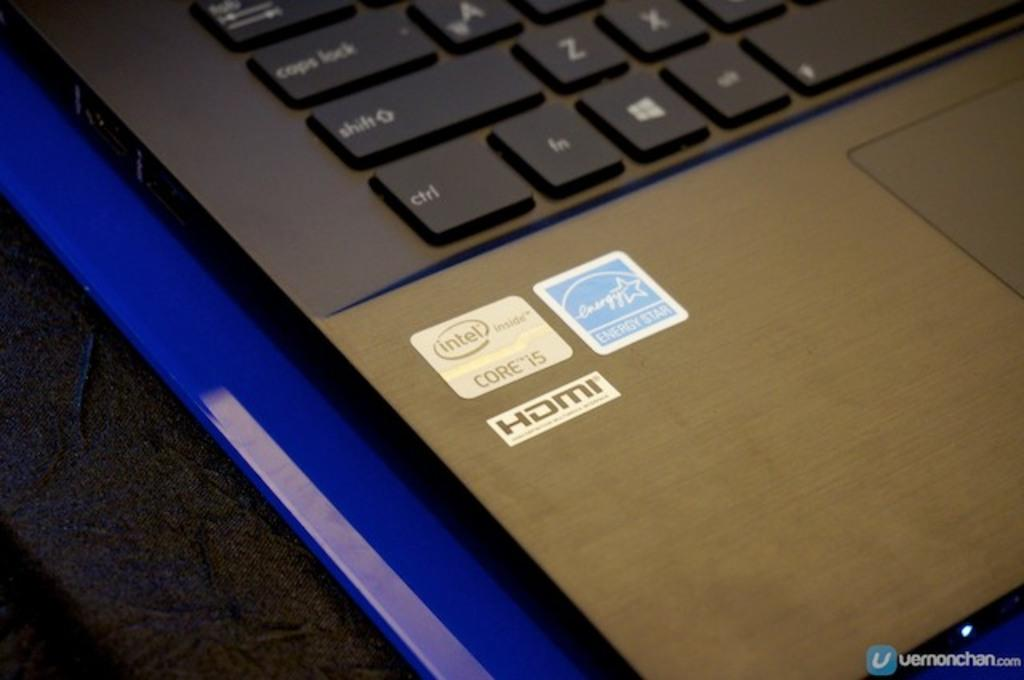Provide a one-sentence caption for the provided image. A close up of a laptop with a sticker that says intel and HDMI. 